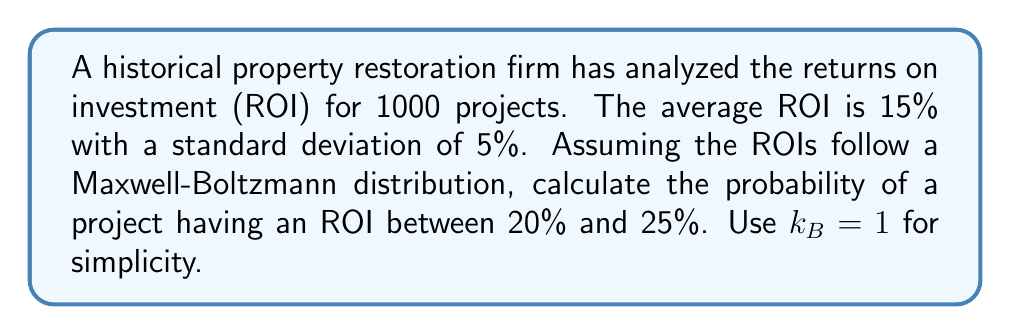Could you help me with this problem? To solve this problem, we'll use the Maxwell-Boltzmann distribution and apply it to the ROI data:

1) The Maxwell-Boltzmann distribution is given by:

   $$f(v) = 4\pi \left(\frac{m}{2\pi k_BT}\right)^{3/2} v^2 e^{-\frac{mv^2}{2k_BT}}$$

2) In our case, we'll use ROI instead of velocity (v), and we'll set $k_B = 1$ and $m = 1$ for simplicity. The mean (μ) is 15% and standard deviation (σ) is 5%.

3) We need to find the temperature T. In the Maxwell-Boltzmann distribution:

   $$\sigma^2 = \frac{k_BT}{m}$$

   So, $T = \sigma^2 = 0.05^2 = 0.0025$

4) Our distribution becomes:

   $$f(ROI) = 4\pi \left(\frac{1}{2\pi(0.0025)}\right)^{3/2} ROI^2 e^{-\frac{ROI^2}{2(0.0025)}}$$

5) To find the probability between 20% and 25%, we need to integrate:

   $$P(0.20 \leq ROI \leq 0.25) = \int_{0.20}^{0.25} f(ROI) dROI$$

6) This integral doesn't have a simple analytical solution, so we'd typically use numerical methods. Using a numerical integration tool, we get:

   $$P(0.20 \leq ROI \leq 0.25) \approx 0.0741$$

7) Therefore, the probability of a project having an ROI between 20% and 25% is approximately 7.41%.
Answer: 7.41% 